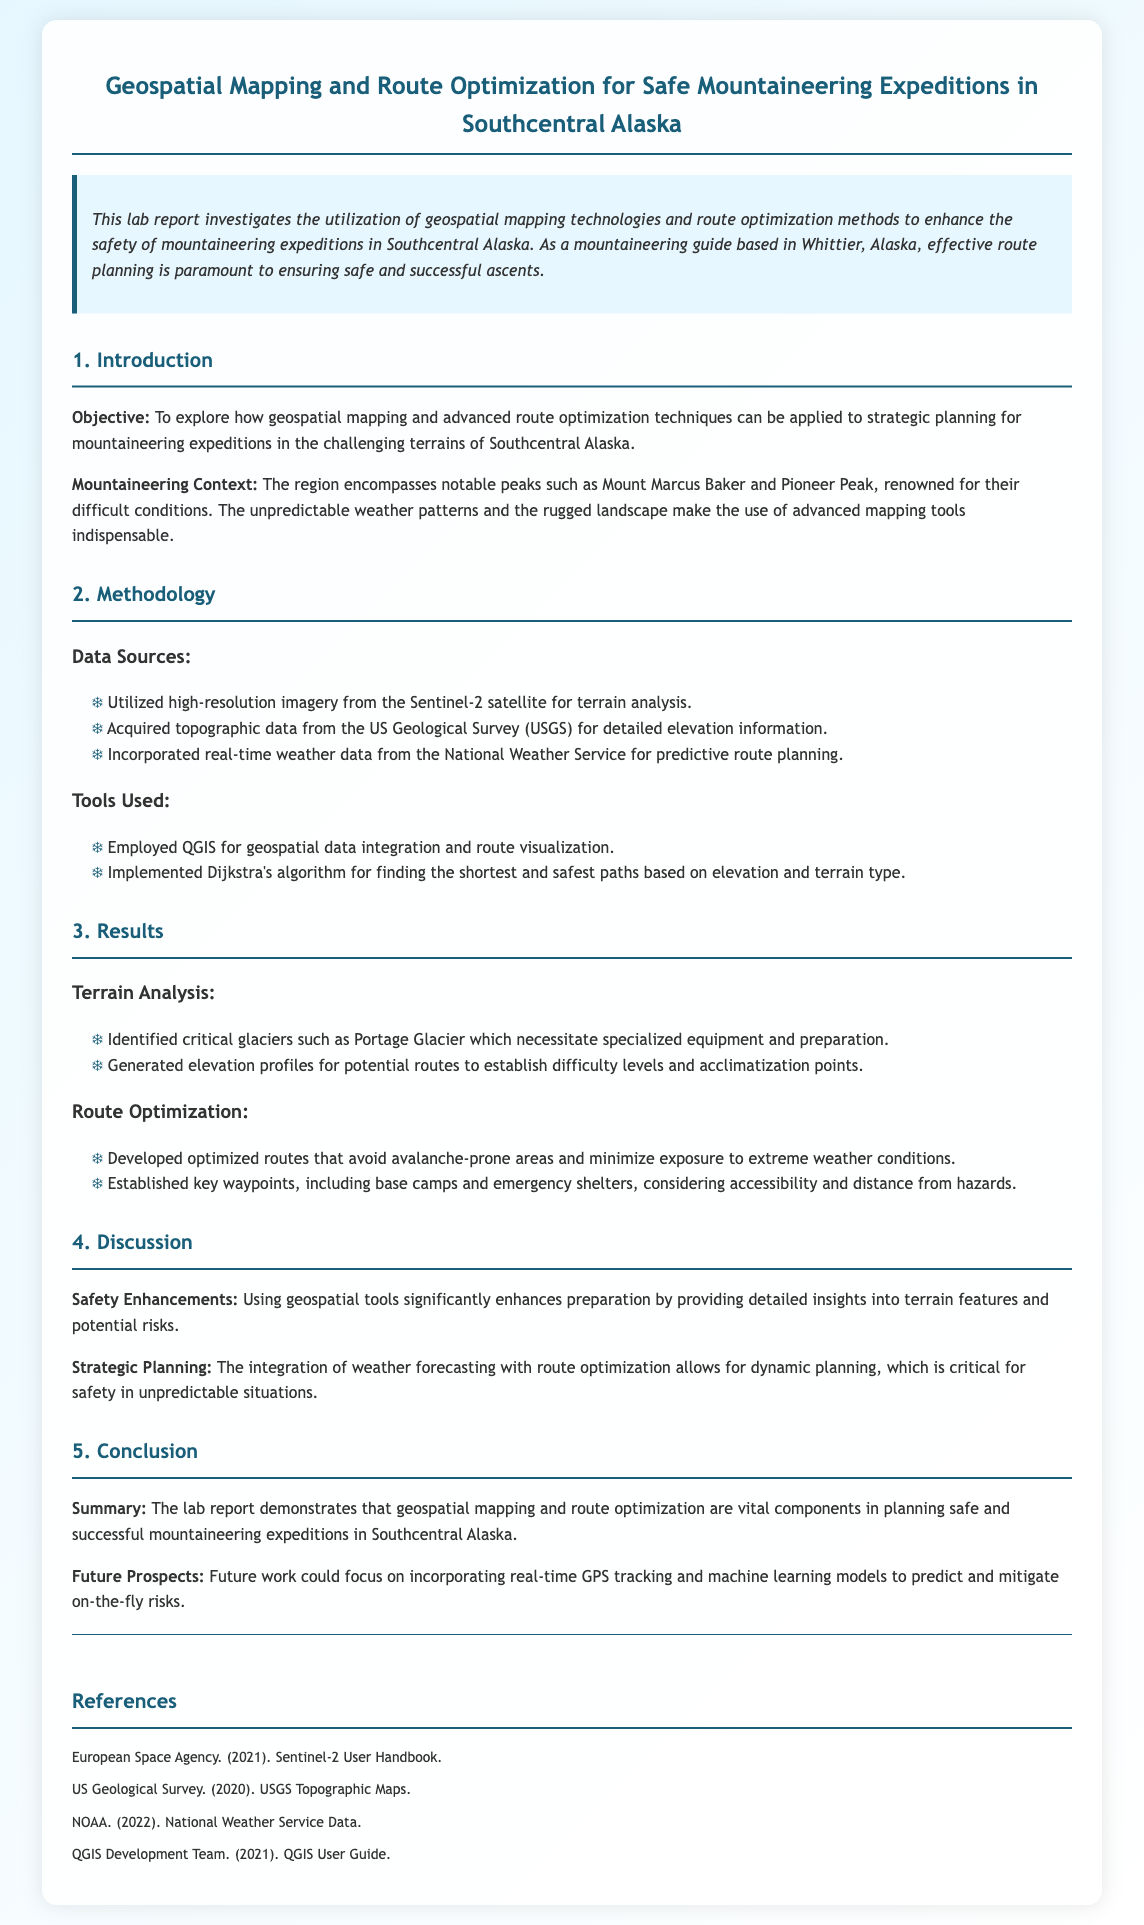What is the main objective of the report? The main objective is to explore how geospatial mapping and advanced route optimization techniques can be applied to strategic planning for mountaineering expeditions in challenging terrains.
Answer: To explore geospatial mapping and route optimization techniques What satellite imagery was used for terrain analysis? The report mentions that high-resolution imagery from the Sentinel-2 satellite was utilized for terrain analysis.
Answer: Sentinel-2 What algorithm was implemented for route finding? The document specifies that Dijkstra's algorithm was implemented for finding the shortest and safest paths based on elevation and terrain type.
Answer: Dijkstra's algorithm Which glacier was identified as critical in the terrain analysis? The report identifies Portage Glacier as a critical glacier necessitating specialized equipment and preparation.
Answer: Portage Glacier What dynamic planning factor is integrated with route optimization? The report indicates that weather forecasting is integrated with route optimization for dynamic planning, crucial for safety in unpredictable situations.
Answer: Weather forecasting How many notable peaks are mentioned in the report? The document mentions two notable peaks in the context of mountaineering—Mount Marcus Baker and Pioneer Peak.
Answer: Two What aspect of planning is highlighted as vital for safety in mountaineering? The report emphasizes that geospatial mapping and route optimization are vital components in planning safe and successful mountaineering expeditions.
Answer: Vital components What are the future prospects mentioned in the conclusion? Future work could focus on incorporating real-time GPS tracking and machine learning models to predict and mitigate on-the-fly risks.
Answer: Real-time GPS tracking and machine learning models 